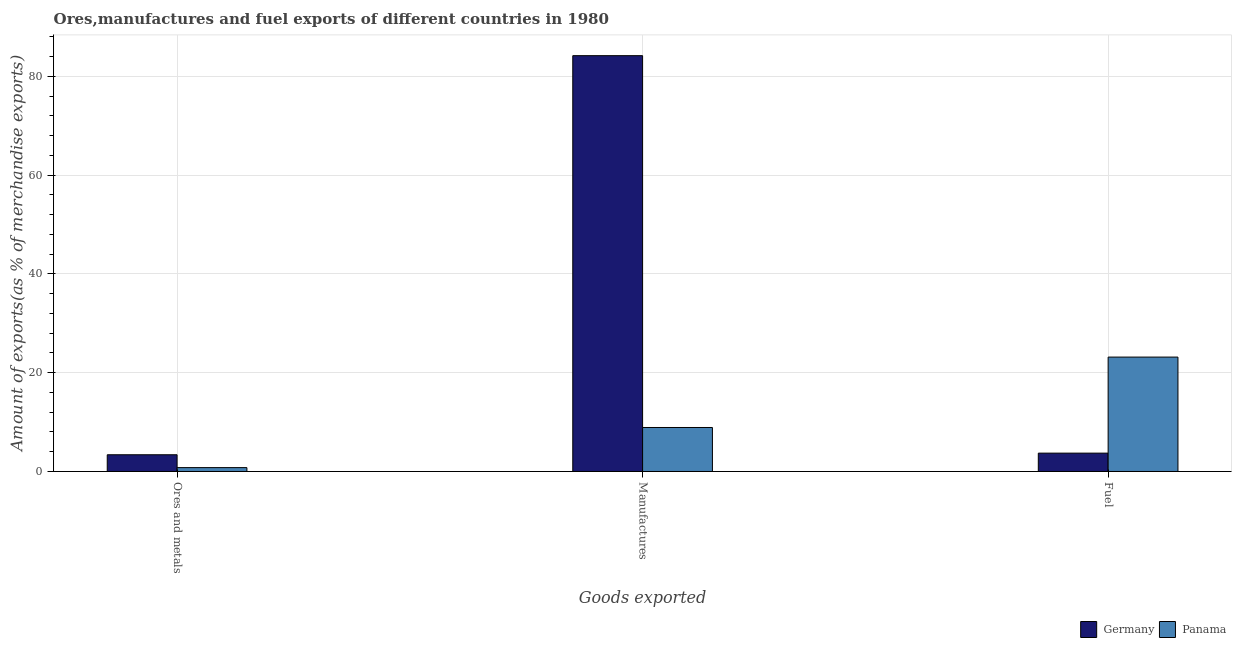Are the number of bars per tick equal to the number of legend labels?
Provide a short and direct response. Yes. Are the number of bars on each tick of the X-axis equal?
Offer a terse response. Yes. How many bars are there on the 1st tick from the left?
Offer a terse response. 2. What is the label of the 2nd group of bars from the left?
Your answer should be compact. Manufactures. What is the percentage of fuel exports in Germany?
Provide a succinct answer. 3.72. Across all countries, what is the maximum percentage of ores and metals exports?
Your answer should be compact. 3.39. Across all countries, what is the minimum percentage of manufactures exports?
Ensure brevity in your answer.  8.91. In which country was the percentage of fuel exports maximum?
Your response must be concise. Panama. In which country was the percentage of ores and metals exports minimum?
Offer a very short reply. Panama. What is the total percentage of manufactures exports in the graph?
Your response must be concise. 93.09. What is the difference between the percentage of ores and metals exports in Germany and that in Panama?
Ensure brevity in your answer.  2.6. What is the difference between the percentage of ores and metals exports in Panama and the percentage of manufactures exports in Germany?
Your answer should be very brief. -83.4. What is the average percentage of fuel exports per country?
Your answer should be very brief. 13.44. What is the difference between the percentage of ores and metals exports and percentage of fuel exports in Germany?
Offer a terse response. -0.33. In how many countries, is the percentage of manufactures exports greater than 72 %?
Your response must be concise. 1. What is the ratio of the percentage of manufactures exports in Panama to that in Germany?
Offer a very short reply. 0.11. Is the difference between the percentage of manufactures exports in Panama and Germany greater than the difference between the percentage of fuel exports in Panama and Germany?
Make the answer very short. No. What is the difference between the highest and the second highest percentage of ores and metals exports?
Provide a short and direct response. 2.6. What is the difference between the highest and the lowest percentage of fuel exports?
Your answer should be compact. 19.44. Is the sum of the percentage of ores and metals exports in Panama and Germany greater than the maximum percentage of fuel exports across all countries?
Give a very brief answer. No. What does the 2nd bar from the left in Ores and metals represents?
Ensure brevity in your answer.  Panama. How many bars are there?
Your answer should be very brief. 6. How many countries are there in the graph?
Ensure brevity in your answer.  2. What is the difference between two consecutive major ticks on the Y-axis?
Ensure brevity in your answer.  20. Are the values on the major ticks of Y-axis written in scientific E-notation?
Offer a very short reply. No. Does the graph contain any zero values?
Provide a succinct answer. No. How many legend labels are there?
Provide a short and direct response. 2. How are the legend labels stacked?
Give a very brief answer. Horizontal. What is the title of the graph?
Ensure brevity in your answer.  Ores,manufactures and fuel exports of different countries in 1980. Does "Denmark" appear as one of the legend labels in the graph?
Your answer should be very brief. No. What is the label or title of the X-axis?
Your answer should be very brief. Goods exported. What is the label or title of the Y-axis?
Your answer should be very brief. Amount of exports(as % of merchandise exports). What is the Amount of exports(as % of merchandise exports) of Germany in Ores and metals?
Your answer should be compact. 3.39. What is the Amount of exports(as % of merchandise exports) in Panama in Ores and metals?
Ensure brevity in your answer.  0.78. What is the Amount of exports(as % of merchandise exports) of Germany in Manufactures?
Offer a very short reply. 84.18. What is the Amount of exports(as % of merchandise exports) in Panama in Manufactures?
Ensure brevity in your answer.  8.91. What is the Amount of exports(as % of merchandise exports) of Germany in Fuel?
Provide a succinct answer. 3.72. What is the Amount of exports(as % of merchandise exports) of Panama in Fuel?
Provide a short and direct response. 23.16. Across all Goods exported, what is the maximum Amount of exports(as % of merchandise exports) of Germany?
Give a very brief answer. 84.18. Across all Goods exported, what is the maximum Amount of exports(as % of merchandise exports) in Panama?
Your answer should be compact. 23.16. Across all Goods exported, what is the minimum Amount of exports(as % of merchandise exports) of Germany?
Give a very brief answer. 3.39. Across all Goods exported, what is the minimum Amount of exports(as % of merchandise exports) in Panama?
Offer a very short reply. 0.78. What is the total Amount of exports(as % of merchandise exports) of Germany in the graph?
Make the answer very short. 91.29. What is the total Amount of exports(as % of merchandise exports) in Panama in the graph?
Your response must be concise. 32.85. What is the difference between the Amount of exports(as % of merchandise exports) of Germany in Ores and metals and that in Manufactures?
Offer a terse response. -80.8. What is the difference between the Amount of exports(as % of merchandise exports) of Panama in Ores and metals and that in Manufactures?
Offer a very short reply. -8.12. What is the difference between the Amount of exports(as % of merchandise exports) of Germany in Ores and metals and that in Fuel?
Offer a very short reply. -0.33. What is the difference between the Amount of exports(as % of merchandise exports) of Panama in Ores and metals and that in Fuel?
Provide a short and direct response. -22.38. What is the difference between the Amount of exports(as % of merchandise exports) of Germany in Manufactures and that in Fuel?
Your response must be concise. 80.47. What is the difference between the Amount of exports(as % of merchandise exports) of Panama in Manufactures and that in Fuel?
Provide a short and direct response. -14.25. What is the difference between the Amount of exports(as % of merchandise exports) in Germany in Ores and metals and the Amount of exports(as % of merchandise exports) in Panama in Manufactures?
Your response must be concise. -5.52. What is the difference between the Amount of exports(as % of merchandise exports) in Germany in Ores and metals and the Amount of exports(as % of merchandise exports) in Panama in Fuel?
Ensure brevity in your answer.  -19.77. What is the difference between the Amount of exports(as % of merchandise exports) in Germany in Manufactures and the Amount of exports(as % of merchandise exports) in Panama in Fuel?
Provide a succinct answer. 61.03. What is the average Amount of exports(as % of merchandise exports) of Germany per Goods exported?
Offer a terse response. 30.43. What is the average Amount of exports(as % of merchandise exports) in Panama per Goods exported?
Your answer should be very brief. 10.95. What is the difference between the Amount of exports(as % of merchandise exports) of Germany and Amount of exports(as % of merchandise exports) of Panama in Ores and metals?
Your answer should be very brief. 2.6. What is the difference between the Amount of exports(as % of merchandise exports) in Germany and Amount of exports(as % of merchandise exports) in Panama in Manufactures?
Ensure brevity in your answer.  75.28. What is the difference between the Amount of exports(as % of merchandise exports) in Germany and Amount of exports(as % of merchandise exports) in Panama in Fuel?
Your answer should be compact. -19.44. What is the ratio of the Amount of exports(as % of merchandise exports) in Germany in Ores and metals to that in Manufactures?
Your answer should be very brief. 0.04. What is the ratio of the Amount of exports(as % of merchandise exports) of Panama in Ores and metals to that in Manufactures?
Your answer should be compact. 0.09. What is the ratio of the Amount of exports(as % of merchandise exports) in Germany in Ores and metals to that in Fuel?
Make the answer very short. 0.91. What is the ratio of the Amount of exports(as % of merchandise exports) of Panama in Ores and metals to that in Fuel?
Your response must be concise. 0.03. What is the ratio of the Amount of exports(as % of merchandise exports) of Germany in Manufactures to that in Fuel?
Keep it short and to the point. 22.65. What is the ratio of the Amount of exports(as % of merchandise exports) in Panama in Manufactures to that in Fuel?
Make the answer very short. 0.38. What is the difference between the highest and the second highest Amount of exports(as % of merchandise exports) in Germany?
Keep it short and to the point. 80.47. What is the difference between the highest and the second highest Amount of exports(as % of merchandise exports) of Panama?
Offer a very short reply. 14.25. What is the difference between the highest and the lowest Amount of exports(as % of merchandise exports) in Germany?
Your answer should be very brief. 80.8. What is the difference between the highest and the lowest Amount of exports(as % of merchandise exports) of Panama?
Ensure brevity in your answer.  22.38. 